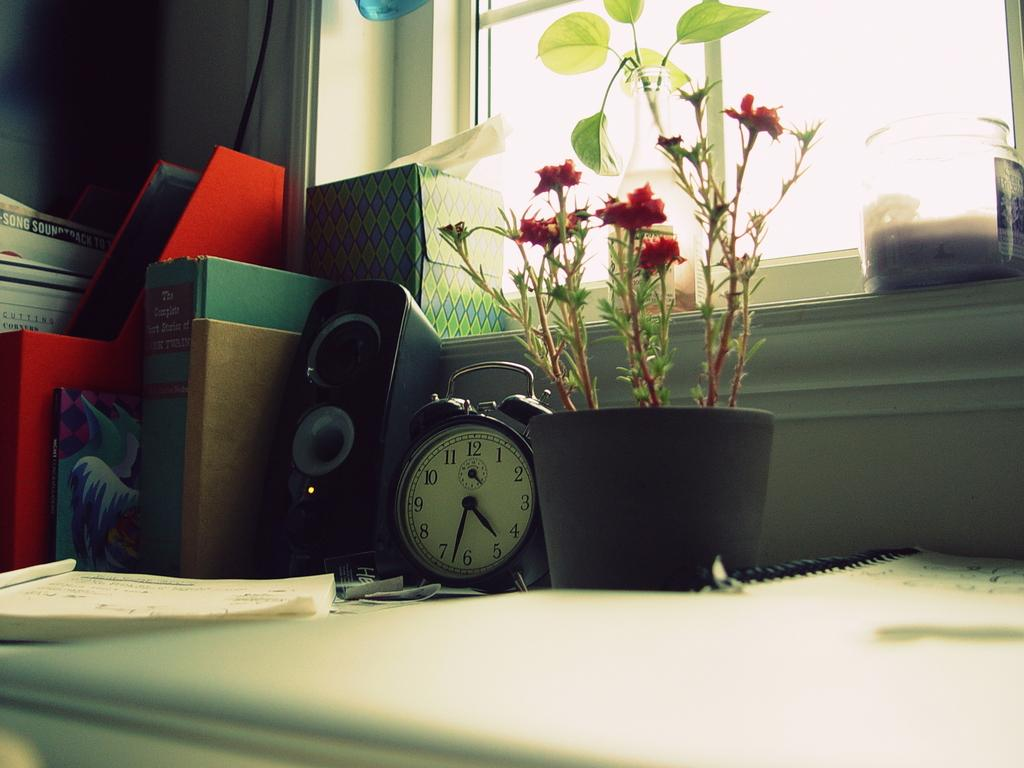<image>
Share a concise interpretation of the image provided. A clock showing 4:33 is on a desk next to flowers, a speaker, and a book. 